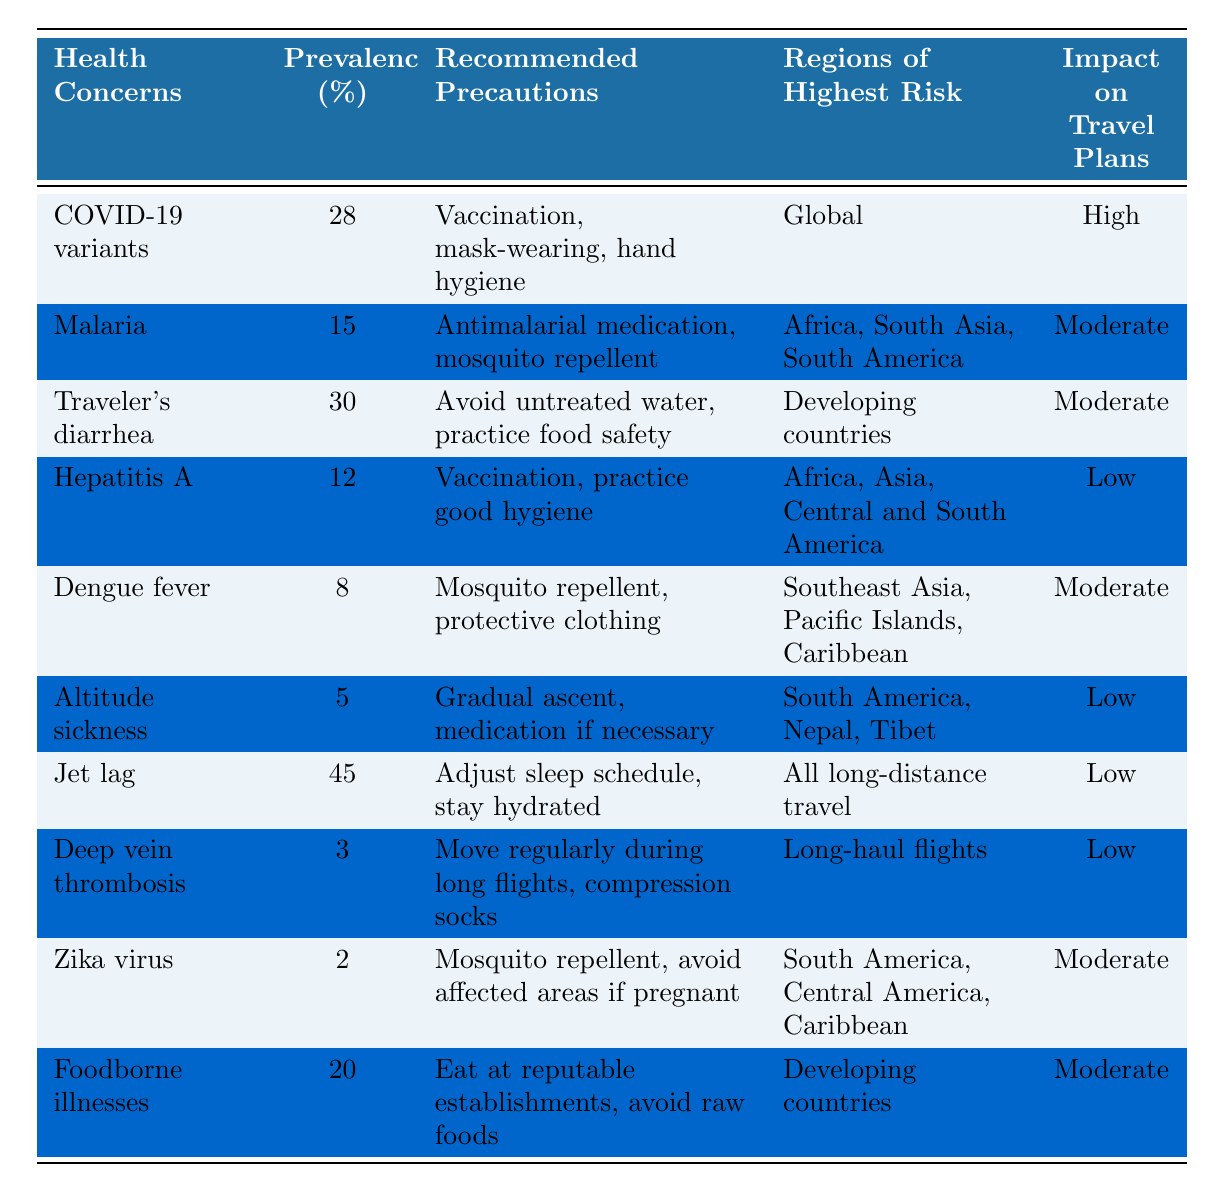What is the health concern with the highest prevalence? The table lists the health concerns along with their prevalence percentages. By scanning the "Prevalence (%)" column, I find that "Traveler's diarrhea" has the highest prevalence at 30%.
Answer: Traveler's diarrhea Which health concern is associated with the highest impact on travel plans? The "Impact on Travel Plans" column indicates that "COVID-19 variants" have a "High" impact, which is the most severe level listed.
Answer: COVID-19 variants How many health concerns have a prevalence of 20% or more? I need to count the number of health concerns with prevalence percentages of 20% or higher. The relevant health concerns are "Traveler's diarrhea" (30%), "COVID-19 variants" (28%), and "Foodborne illnesses" (20%), totaling 3 concerns.
Answer: 3 Is dengue fever associated with a low impact on travel plans? Checking the table, "Dengue fever" is noted with a "Moderate" impact on travel plans, indicating that it is not classified as low.
Answer: No What is the recommended precaution for malaria? Looking at the "Recommended Precautions" column under malaria, the recommended precautions are "Antimalarial medication, mosquito repellent."
Answer: Antimalarial medication, mosquito repellent Which two health concerns have the lowest prevalence percentages? The table shows "Zika virus" has a prevalence of 2% and "Deep vein thrombosis" has a prevalence of 3%. Therefore, these two concerns have the lowest prevalence percentages.
Answer: Zika virus and Deep vein thrombosis What is the average prevalence of health concerns that have a moderate impact on travel plans? The health concerns with a "Moderate" impact are Malaria (15%), Traveler's diarrhea (30%), Dengue fever (8%), Zika virus (2%), and Foodborne illnesses (20%). Summing these gives 15 + 30 + 8 + 2 + 20 = 75. Dividing by 5 gives an average of 15.
Answer: 15 How many regions of highest risk are associated with traveler’s diarrhea? The table indicates that "Traveler's diarrhea" is associated with "Developing countries" as the region of highest risk, which counts as one region.
Answer: 1 What precautions should be taken for altitude sickness? Referring to the "Recommended Precautions" column for altitude sickness, it mentions "Gradual ascent, medication if necessary."
Answer: Gradual ascent, medication if necessary Which health concern has the same prevalence as malaria, and what is that percentage? The table shows both "Malaria" and "Hepatitis A" have respective prevalence values of 15% and 12%, which means they do not share the same prevalence.
Answer: None 